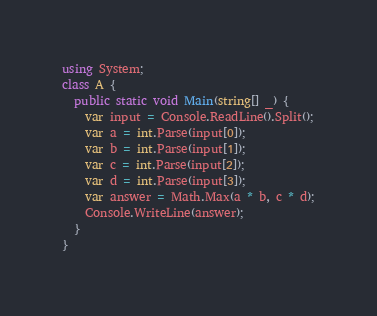<code> <loc_0><loc_0><loc_500><loc_500><_C#_>using System;
class A {
  public static void Main(string[] _) {
    var input = Console.ReadLine().Split();
    var a = int.Parse(input[0]);
    var b = int.Parse(input[1]);
    var c = int.Parse(input[2]);
    var d = int.Parse(input[3]);
    var answer = Math.Max(a * b, c * d);
    Console.WriteLine(answer);
  }
}
</code> 